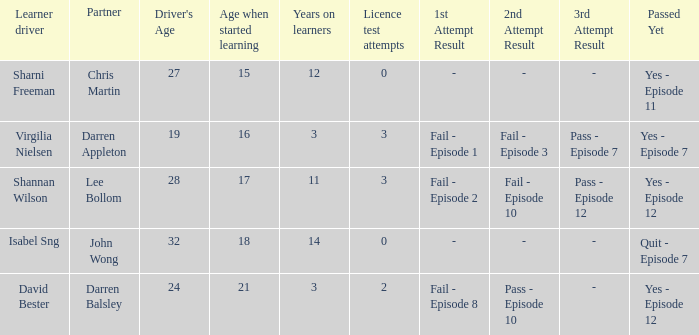Could you parse the entire table as a dict? {'header': ['Learner driver', 'Partner', "Driver's Age", 'Age when started learning', 'Years on learners', 'Licence test attempts', '1st Attempt Result', '2nd Attempt Result', '3rd Attempt Result', 'Passed Yet'], 'rows': [['Sharni Freeman', 'Chris Martin', '27', '15', '12', '0', '-', '-', '-', 'Yes - Episode 11'], ['Virgilia Nielsen', 'Darren Appleton', '19', '16', '3', '3', 'Fail - Episode 1', 'Fail - Episode 3', 'Pass - Episode 7', 'Yes - Episode 7'], ['Shannan Wilson', 'Lee Bollom', '28', '17', '11', '3', 'Fail - Episode 2', 'Fail - Episode 10', 'Pass - Episode 12', 'Yes - Episode 12'], ['Isabel Sng', 'John Wong', '32', '18', '14', '0', '-', '-', '-', 'Quit - Episode 7'], ['David Bester', 'Darren Balsley', '24', '21', '3', '2', 'Fail - Episode 8', 'Pass - Episode 10', '-', 'Yes - Episode 12']]} Which driver is older than 24 and has more than 0 licence test attempts? Shannan Wilson. 